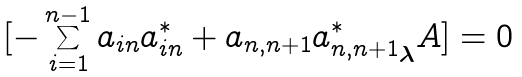<formula> <loc_0><loc_0><loc_500><loc_500>[ - \sum _ { i = 1 } ^ { n - 1 } a _ { i n } a _ { i n } ^ { * } + a _ { n , n + 1 } { a _ { n , n + 1 } ^ { * } } _ { \boldsymbol \lambda } A ] = 0</formula> 